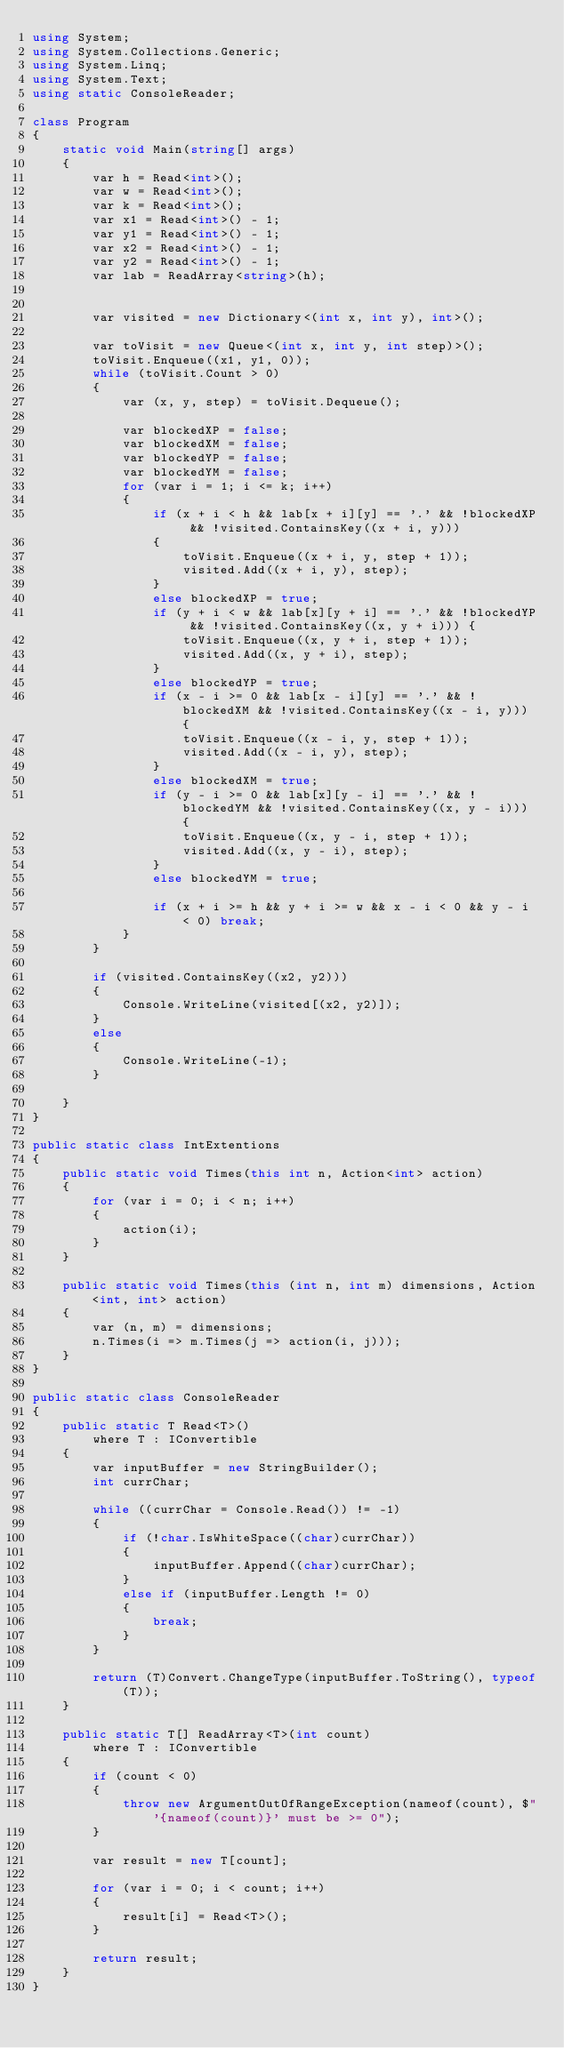<code> <loc_0><loc_0><loc_500><loc_500><_C#_>using System;
using System.Collections.Generic;
using System.Linq;
using System.Text;
using static ConsoleReader;

class Program
{
    static void Main(string[] args)
    {
        var h = Read<int>();
        var w = Read<int>();
        var k = Read<int>();
        var x1 = Read<int>() - 1;
        var y1 = Read<int>() - 1;
        var x2 = Read<int>() - 1;
        var y2 = Read<int>() - 1;
        var lab = ReadArray<string>(h);


        var visited = new Dictionary<(int x, int y), int>();

        var toVisit = new Queue<(int x, int y, int step)>();
        toVisit.Enqueue((x1, y1, 0));
        while (toVisit.Count > 0)
        {
            var (x, y, step) = toVisit.Dequeue();

            var blockedXP = false;
            var blockedXM = false;
            var blockedYP = false;
            var blockedYM = false;
            for (var i = 1; i <= k; i++)
            {
                if (x + i < h && lab[x + i][y] == '.' && !blockedXP && !visited.ContainsKey((x + i, y)))
                {
                    toVisit.Enqueue((x + i, y, step + 1));
                    visited.Add((x + i, y), step);
                }
                else blockedXP = true;
                if (y + i < w && lab[x][y + i] == '.' && !blockedYP && !visited.ContainsKey((x, y + i))) {
                    toVisit.Enqueue((x, y + i, step + 1));
                    visited.Add((x, y + i), step);
                }
                else blockedYP = true;
                if (x - i >= 0 && lab[x - i][y] == '.' && !blockedXM && !visited.ContainsKey((x - i, y))) {
                    toVisit.Enqueue((x - i, y, step + 1));
                    visited.Add((x - i, y), step);
                }
                else blockedXM = true;
                if (y - i >= 0 && lab[x][y - i] == '.' && !blockedYM && !visited.ContainsKey((x, y - i))) {
                    toVisit.Enqueue((x, y - i, step + 1));
                    visited.Add((x, y - i), step);
                }
                else blockedYM = true;

                if (x + i >= h && y + i >= w && x - i < 0 && y - i < 0) break;
            }
        }

        if (visited.ContainsKey((x2, y2)))
        {
            Console.WriteLine(visited[(x2, y2)]);
        }
        else
        {
            Console.WriteLine(-1);
        }

    }
}

public static class IntExtentions
{
    public static void Times(this int n, Action<int> action)
    {
        for (var i = 0; i < n; i++)
        {
            action(i);
        }
    }

    public static void Times(this (int n, int m) dimensions, Action<int, int> action)
    {
        var (n, m) = dimensions;
        n.Times(i => m.Times(j => action(i, j)));
    }
}

public static class ConsoleReader
{
    public static T Read<T>()
        where T : IConvertible
    {
        var inputBuffer = new StringBuilder();
        int currChar;

        while ((currChar = Console.Read()) != -1)
        {
            if (!char.IsWhiteSpace((char)currChar))
            {
                inputBuffer.Append((char)currChar);
            }
            else if (inputBuffer.Length != 0)
            {
                break;
            }
        }

        return (T)Convert.ChangeType(inputBuffer.ToString(), typeof(T));
    }

    public static T[] ReadArray<T>(int count)
        where T : IConvertible
    {
        if (count < 0)
        {
            throw new ArgumentOutOfRangeException(nameof(count), $"'{nameof(count)}' must be >= 0");
        }

        var result = new T[count];

        for (var i = 0; i < count; i++)
        {
            result[i] = Read<T>();
        }

        return result;
    }
}</code> 